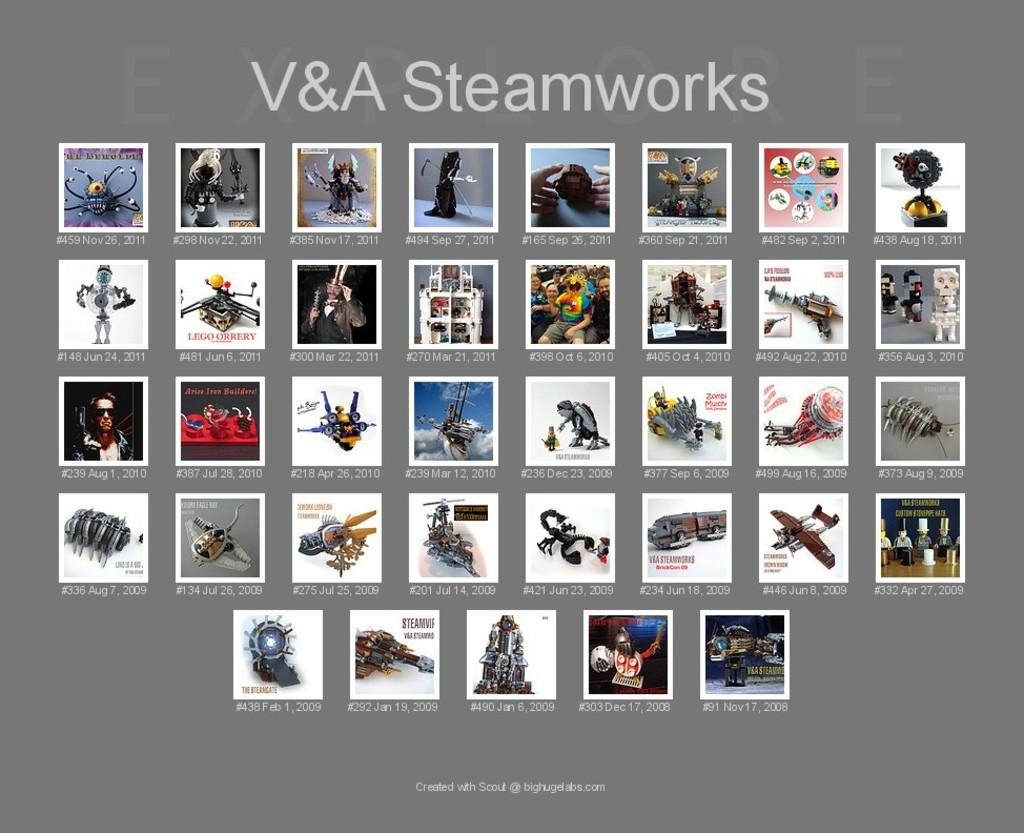<image>
Describe the image concisely. The picture collage is titled V&A Steamworks and has photos taken from 2008 to 2011.. 